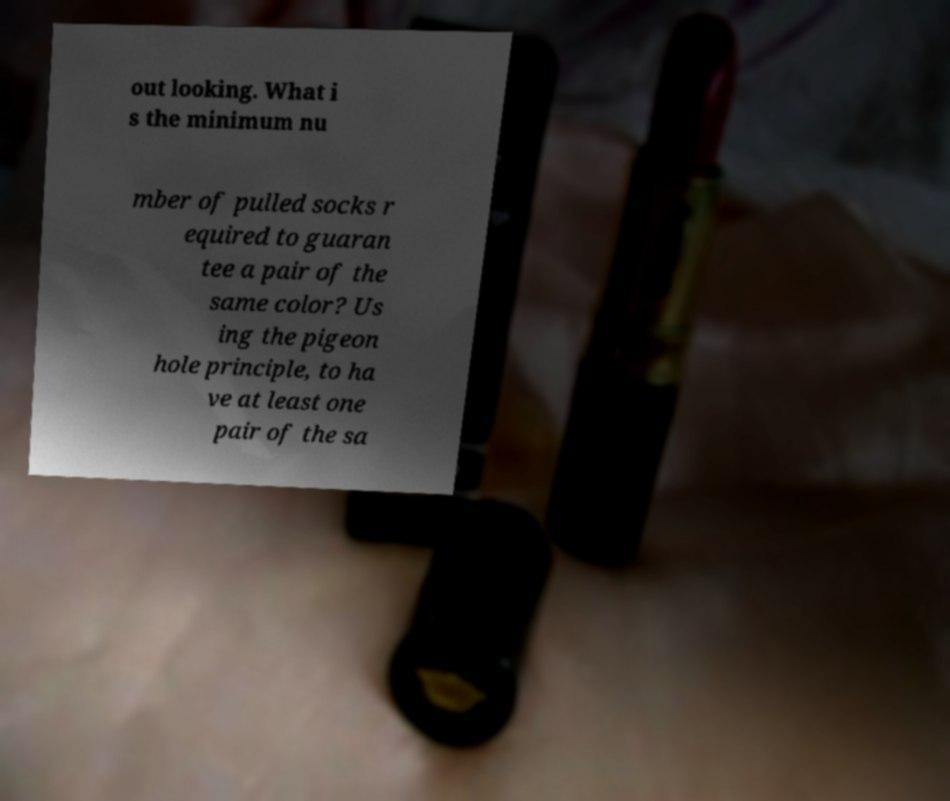Can you read and provide the text displayed in the image?This photo seems to have some interesting text. Can you extract and type it out for me? out looking. What i s the minimum nu mber of pulled socks r equired to guaran tee a pair of the same color? Us ing the pigeon hole principle, to ha ve at least one pair of the sa 